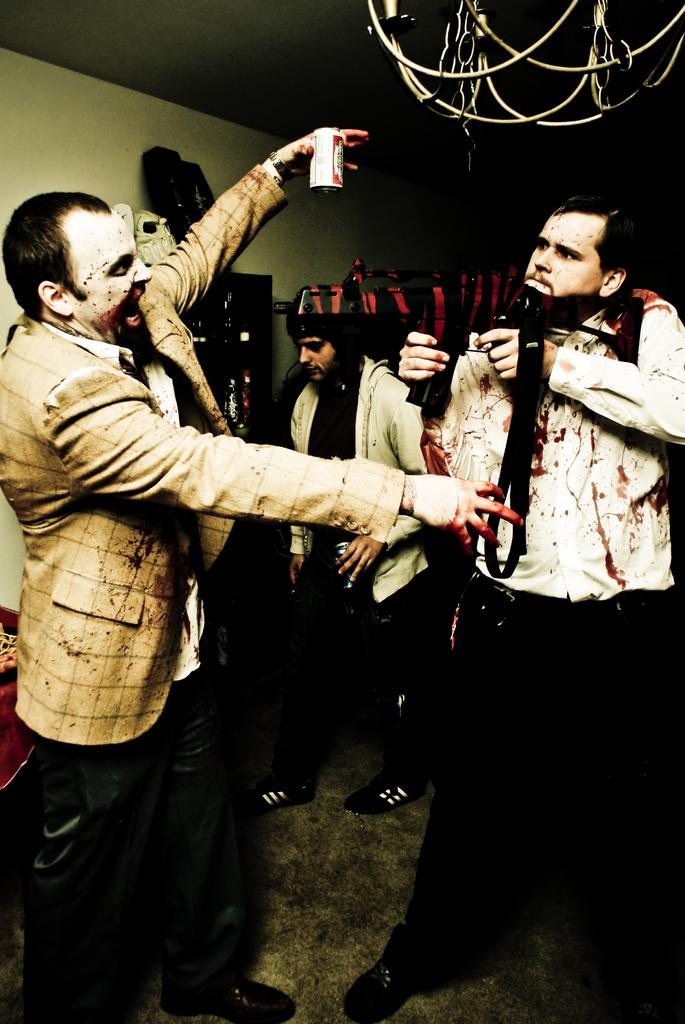What is present in the background of the image? There is a wall in the image. Can you describe the people in the image? There are people in the image. What is one person on the left side holding? One person on the left side is holding a tin. What type of toys can be seen in the image? There are no toys present in the image. What medical procedure is being performed on the person in the image? There is no indication of a medical procedure or hospital setting in the image. 